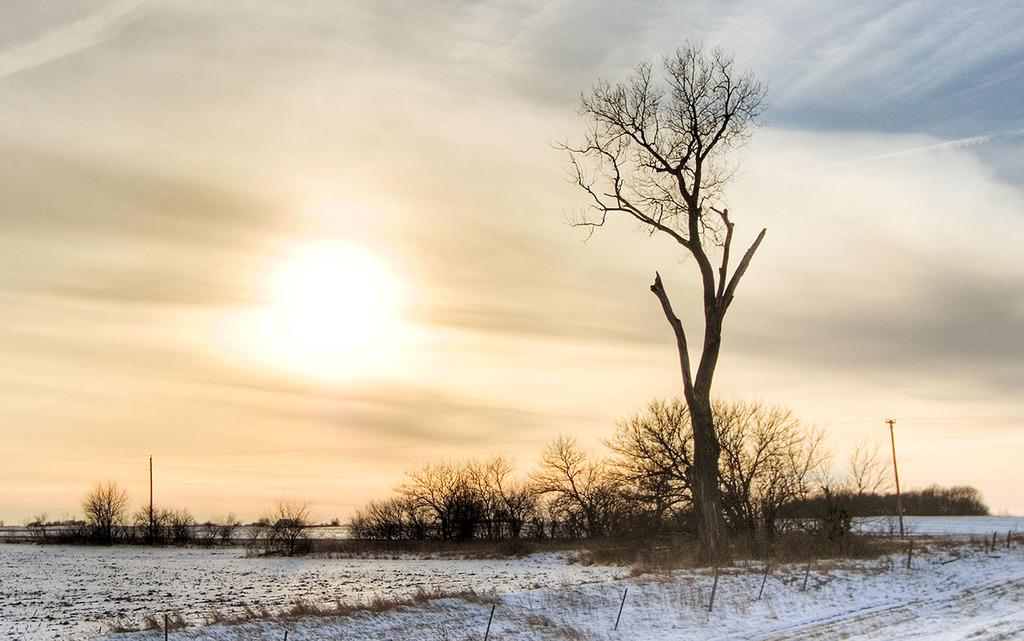What type of weather condition is depicted in the image? There is snow in the image, indicating a cold and wintry weather condition. What type of structure can be seen in the image? There is fencing in the image. What type of natural elements are present in the image? There are trees in the image. What else can be seen in the image besides the trees and fencing? There are poles in the image. What is the color of the sky in the background of the image? The sky in the background is a combination of white and blue colors. What type of expert advice can be seen in the image? There is no expert advice present in the image; it primarily features snow, fencing, trees, poles, and a combination of white and blue sky. What is the texture of the butter in the image? There is no butter present in the image, so it is not possible to determine its texture. 